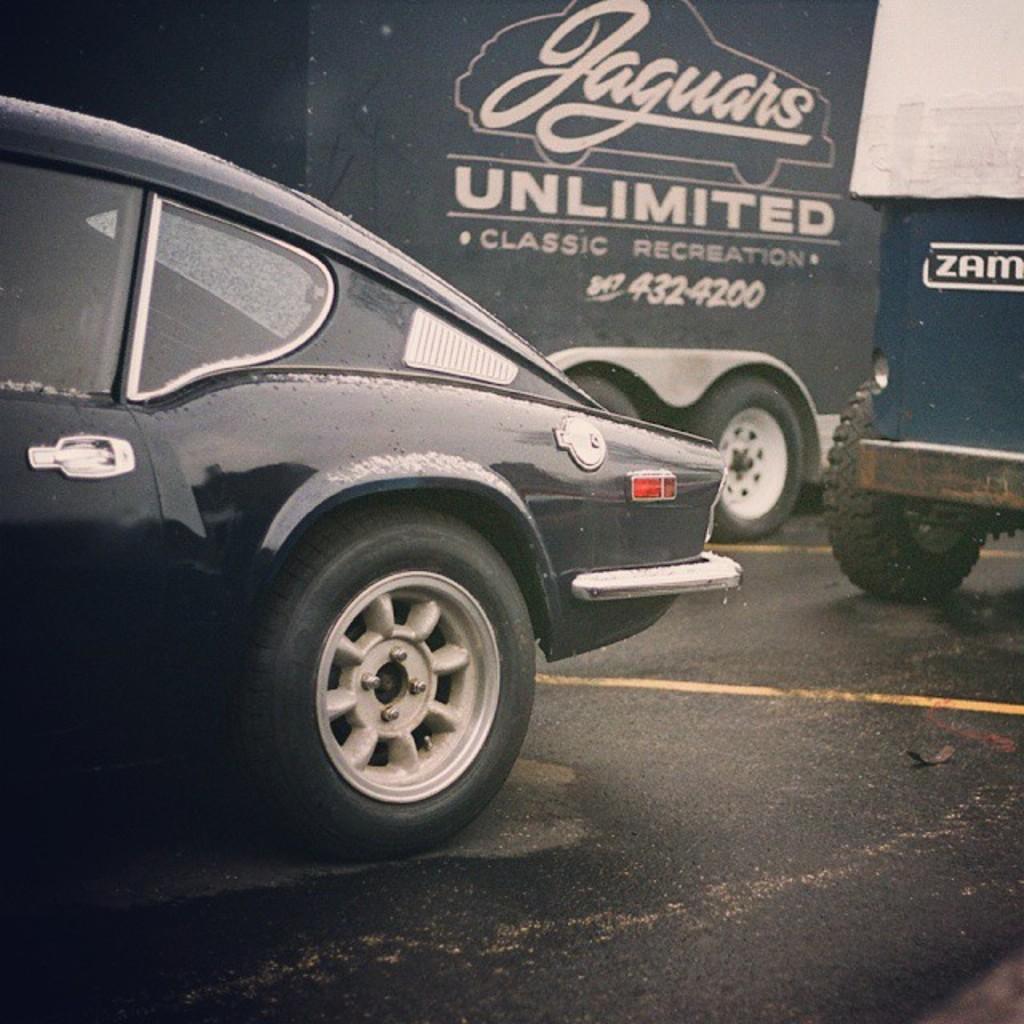In one or two sentences, can you explain what this image depicts? In this image we can see the car on the road and it is on the left side. Here we can see two vehicles on the road and they are on the right side. 